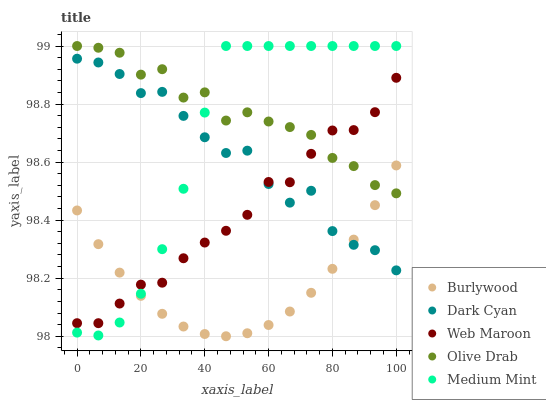Does Burlywood have the minimum area under the curve?
Answer yes or no. Yes. Does Olive Drab have the maximum area under the curve?
Answer yes or no. Yes. Does Dark Cyan have the minimum area under the curve?
Answer yes or no. No. Does Dark Cyan have the maximum area under the curve?
Answer yes or no. No. Is Burlywood the smoothest?
Answer yes or no. Yes. Is Dark Cyan the roughest?
Answer yes or no. Yes. Is Web Maroon the smoothest?
Answer yes or no. No. Is Web Maroon the roughest?
Answer yes or no. No. Does Burlywood have the lowest value?
Answer yes or no. Yes. Does Dark Cyan have the lowest value?
Answer yes or no. No. Does Medium Mint have the highest value?
Answer yes or no. Yes. Does Dark Cyan have the highest value?
Answer yes or no. No. Is Dark Cyan less than Olive Drab?
Answer yes or no. Yes. Is Olive Drab greater than Dark Cyan?
Answer yes or no. Yes. Does Web Maroon intersect Burlywood?
Answer yes or no. Yes. Is Web Maroon less than Burlywood?
Answer yes or no. No. Is Web Maroon greater than Burlywood?
Answer yes or no. No. Does Dark Cyan intersect Olive Drab?
Answer yes or no. No. 